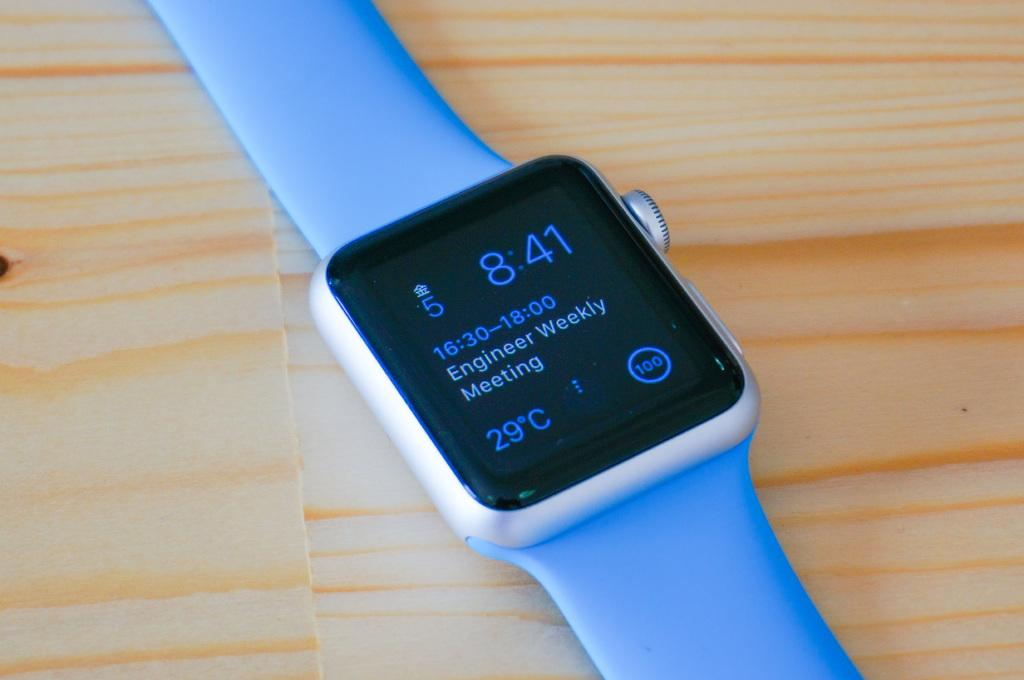<image>
Relay a brief, clear account of the picture shown. the number 8:41 that is on a watch 